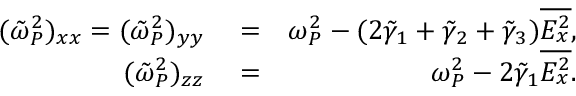<formula> <loc_0><loc_0><loc_500><loc_500>\begin{array} { r l r } { ( \tilde { \omega } _ { P } ^ { 2 } ) _ { x x } = ( \tilde { \omega } _ { P } ^ { 2 } ) _ { y y } } & = } & { \omega _ { P } ^ { 2 } - ( 2 \tilde { \gamma } _ { 1 } + \tilde { \gamma } _ { 2 } + \tilde { \gamma } _ { 3 } ) \overline { { E _ { x } ^ { 2 } } } , } \\ { ( \tilde { \omega } _ { P } ^ { 2 } ) _ { z z } } & = } & { \omega _ { P } ^ { 2 } - 2 \tilde { \gamma } _ { 1 } \overline { { E _ { x } ^ { 2 } } } . } \end{array}</formula> 